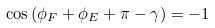Convert formula to latex. <formula><loc_0><loc_0><loc_500><loc_500>\cos { ( \phi _ { F } + \phi _ { E } + \pi - \gamma ) } = - 1</formula> 